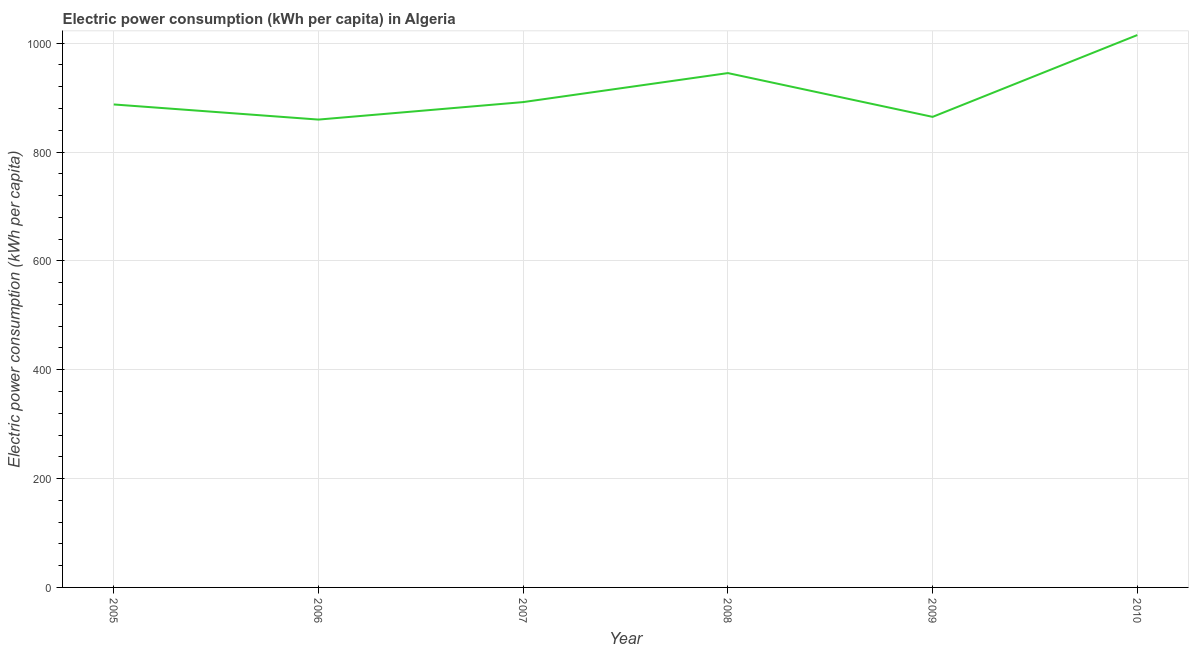What is the electric power consumption in 2010?
Offer a very short reply. 1014.98. Across all years, what is the maximum electric power consumption?
Give a very brief answer. 1014.98. Across all years, what is the minimum electric power consumption?
Make the answer very short. 859.66. What is the sum of the electric power consumption?
Keep it short and to the point. 5463.66. What is the difference between the electric power consumption in 2007 and 2009?
Your answer should be very brief. 27.16. What is the average electric power consumption per year?
Make the answer very short. 910.61. What is the median electric power consumption?
Keep it short and to the point. 889.63. What is the ratio of the electric power consumption in 2006 to that in 2009?
Offer a very short reply. 0.99. Is the electric power consumption in 2009 less than that in 2010?
Your response must be concise. Yes. What is the difference between the highest and the second highest electric power consumption?
Provide a succinct answer. 69.88. What is the difference between the highest and the lowest electric power consumption?
Offer a very short reply. 155.32. In how many years, is the electric power consumption greater than the average electric power consumption taken over all years?
Your answer should be very brief. 2. Does the electric power consumption monotonically increase over the years?
Provide a succinct answer. No. How many lines are there?
Make the answer very short. 1. How many years are there in the graph?
Your answer should be very brief. 6. What is the difference between two consecutive major ticks on the Y-axis?
Ensure brevity in your answer.  200. Does the graph contain any zero values?
Your answer should be compact. No. Does the graph contain grids?
Offer a terse response. Yes. What is the title of the graph?
Keep it short and to the point. Electric power consumption (kWh per capita) in Algeria. What is the label or title of the X-axis?
Provide a succinct answer. Year. What is the label or title of the Y-axis?
Your response must be concise. Electric power consumption (kWh per capita). What is the Electric power consumption (kWh per capita) of 2005?
Provide a succinct answer. 887.46. What is the Electric power consumption (kWh per capita) in 2006?
Keep it short and to the point. 859.66. What is the Electric power consumption (kWh per capita) in 2007?
Make the answer very short. 891.81. What is the Electric power consumption (kWh per capita) in 2008?
Your answer should be compact. 945.1. What is the Electric power consumption (kWh per capita) in 2009?
Provide a succinct answer. 864.65. What is the Electric power consumption (kWh per capita) in 2010?
Provide a short and direct response. 1014.98. What is the difference between the Electric power consumption (kWh per capita) in 2005 and 2006?
Provide a succinct answer. 27.8. What is the difference between the Electric power consumption (kWh per capita) in 2005 and 2007?
Provide a short and direct response. -4.34. What is the difference between the Electric power consumption (kWh per capita) in 2005 and 2008?
Ensure brevity in your answer.  -57.64. What is the difference between the Electric power consumption (kWh per capita) in 2005 and 2009?
Your response must be concise. 22.82. What is the difference between the Electric power consumption (kWh per capita) in 2005 and 2010?
Provide a short and direct response. -127.52. What is the difference between the Electric power consumption (kWh per capita) in 2006 and 2007?
Provide a short and direct response. -32.14. What is the difference between the Electric power consumption (kWh per capita) in 2006 and 2008?
Offer a very short reply. -85.44. What is the difference between the Electric power consumption (kWh per capita) in 2006 and 2009?
Your answer should be very brief. -4.98. What is the difference between the Electric power consumption (kWh per capita) in 2006 and 2010?
Offer a very short reply. -155.32. What is the difference between the Electric power consumption (kWh per capita) in 2007 and 2008?
Offer a terse response. -53.3. What is the difference between the Electric power consumption (kWh per capita) in 2007 and 2009?
Your answer should be compact. 27.16. What is the difference between the Electric power consumption (kWh per capita) in 2007 and 2010?
Provide a short and direct response. -123.18. What is the difference between the Electric power consumption (kWh per capita) in 2008 and 2009?
Offer a terse response. 80.46. What is the difference between the Electric power consumption (kWh per capita) in 2008 and 2010?
Offer a very short reply. -69.88. What is the difference between the Electric power consumption (kWh per capita) in 2009 and 2010?
Offer a terse response. -150.33. What is the ratio of the Electric power consumption (kWh per capita) in 2005 to that in 2006?
Offer a very short reply. 1.03. What is the ratio of the Electric power consumption (kWh per capita) in 2005 to that in 2008?
Your response must be concise. 0.94. What is the ratio of the Electric power consumption (kWh per capita) in 2005 to that in 2009?
Your answer should be compact. 1.03. What is the ratio of the Electric power consumption (kWh per capita) in 2005 to that in 2010?
Make the answer very short. 0.87. What is the ratio of the Electric power consumption (kWh per capita) in 2006 to that in 2008?
Ensure brevity in your answer.  0.91. What is the ratio of the Electric power consumption (kWh per capita) in 2006 to that in 2010?
Your answer should be very brief. 0.85. What is the ratio of the Electric power consumption (kWh per capita) in 2007 to that in 2008?
Offer a very short reply. 0.94. What is the ratio of the Electric power consumption (kWh per capita) in 2007 to that in 2009?
Offer a terse response. 1.03. What is the ratio of the Electric power consumption (kWh per capita) in 2007 to that in 2010?
Make the answer very short. 0.88. What is the ratio of the Electric power consumption (kWh per capita) in 2008 to that in 2009?
Offer a very short reply. 1.09. What is the ratio of the Electric power consumption (kWh per capita) in 2009 to that in 2010?
Your answer should be very brief. 0.85. 